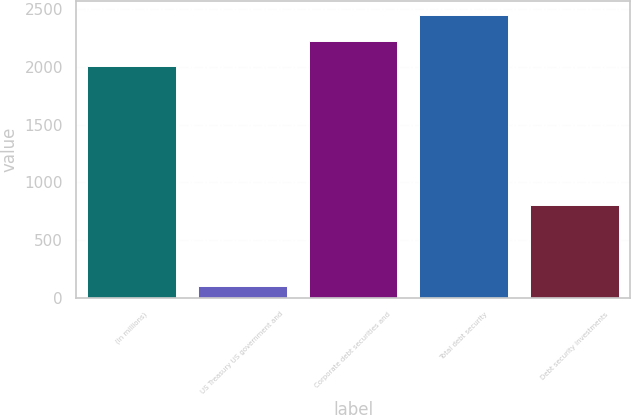Convert chart. <chart><loc_0><loc_0><loc_500><loc_500><bar_chart><fcel>(in millions)<fcel>US Treasury US government and<fcel>Corporate debt securities and<fcel>Total debt security<fcel>Debt security investments<nl><fcel>2007<fcel>106<fcel>2225.8<fcel>2444.6<fcel>802<nl></chart> 